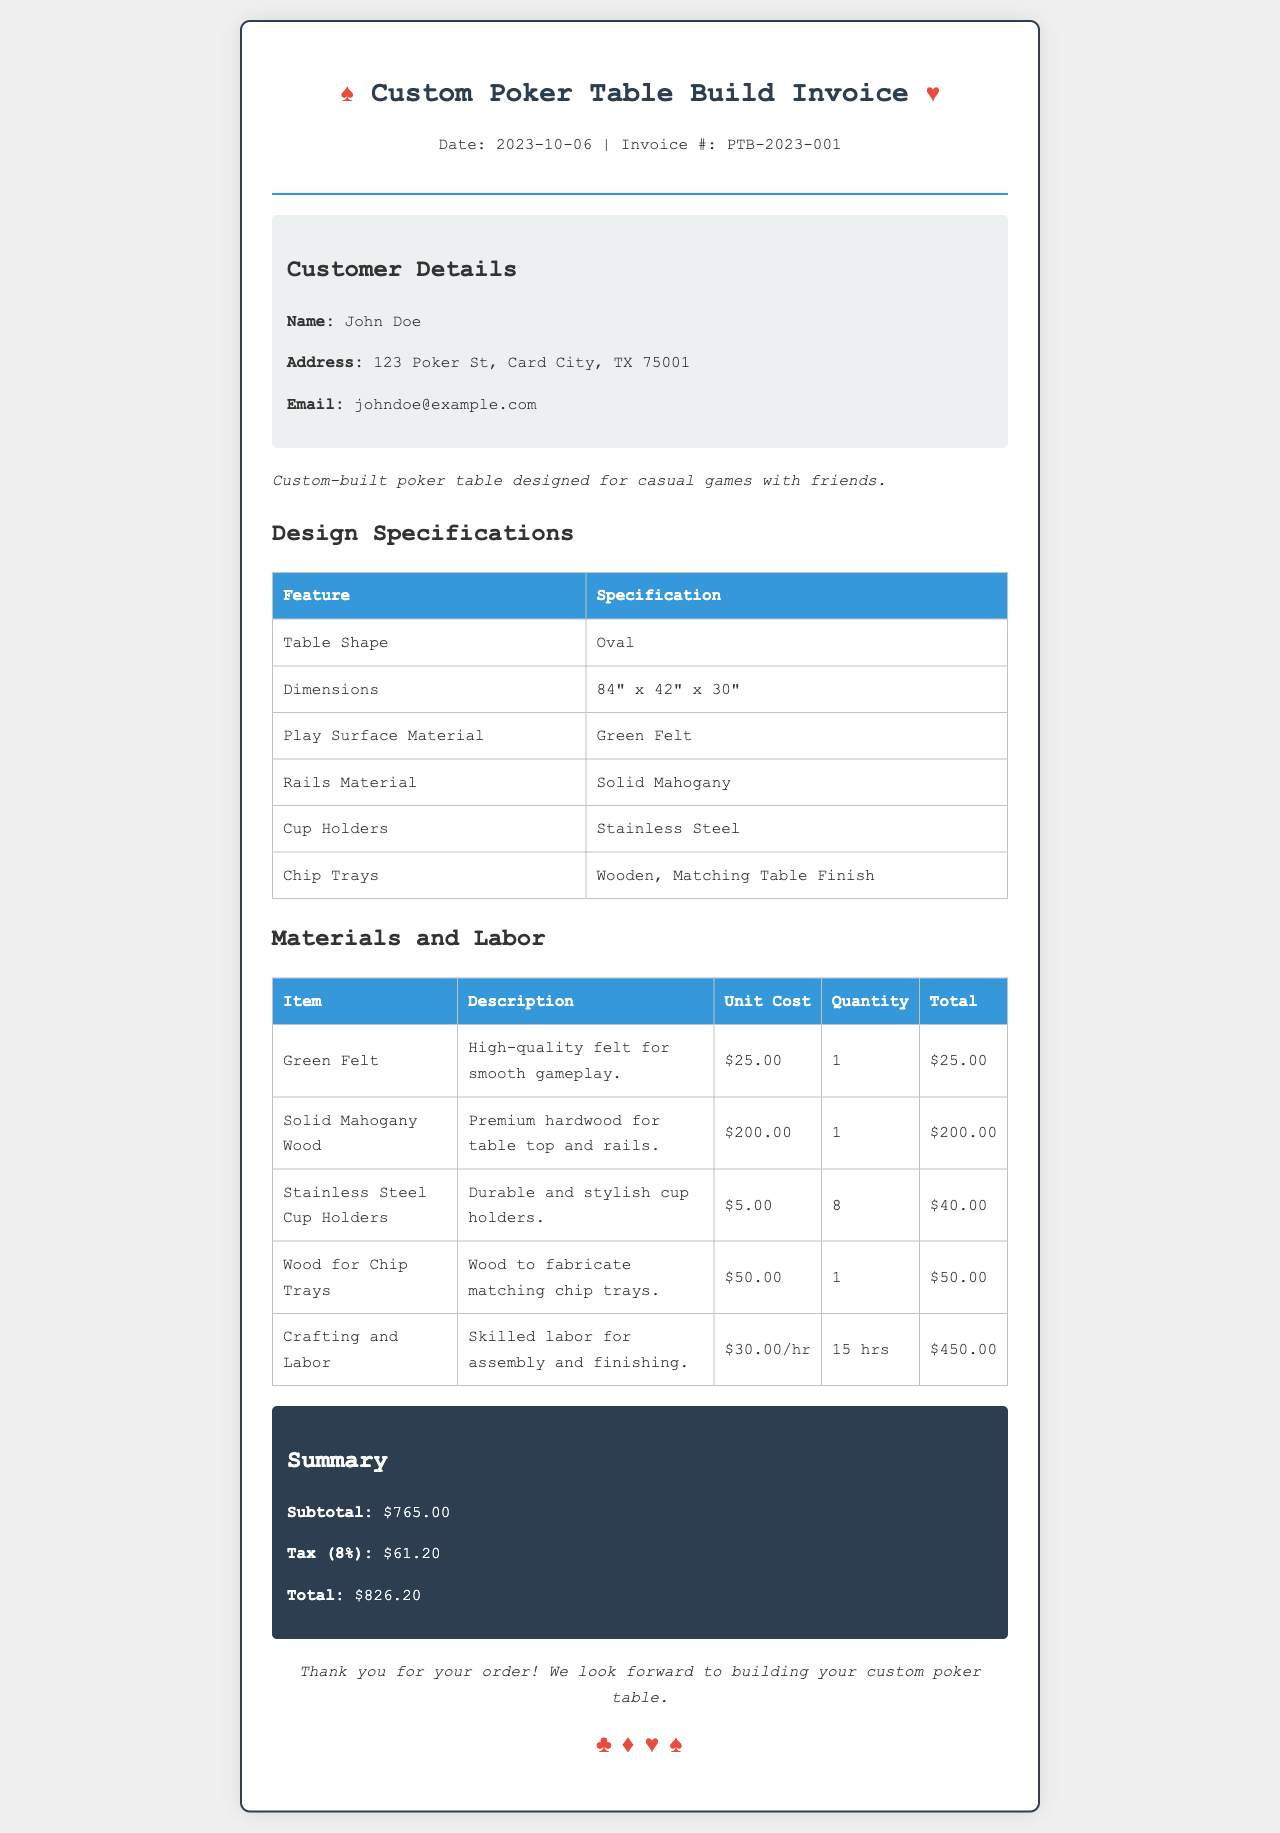What is the invoice number? The invoice number is provided in the header section of the document, which indicates PTB-2023-001.
Answer: PTB-2023-001 Who is the customer? The customer details are listed under 'Customer Details'; the name is John Doe.
Answer: John Doe What is the date of the invoice? The date of the invoice is mentioned in the header, which states October 6, 2023.
Answer: October 6, 2023 What is the subtotal amount? The subtotal is calculated and shown in the summary section of the invoice, which is $765.00.
Answer: $765.00 How many hours were billed for labor? The labor hours are listed under materials and labor; it specifies 15 hours.
Answer: 15 hrs What material is used for the play surface? The material for the play surface is stated in the design specifications section as green felt.
Answer: Green Felt What is the total cost including tax? The total cost is explicitly stated in the summary section, accounting for tax, which is $826.20.
Answer: $826.20 What shape is the poker table? The shape of the poker table is mentioned in the design specifications, which is oval.
Answer: Oval What type of wood is used for the table rails? The type of wood used for the rails is noted in the design specifications as solid mahogany.
Answer: Solid Mahogany 